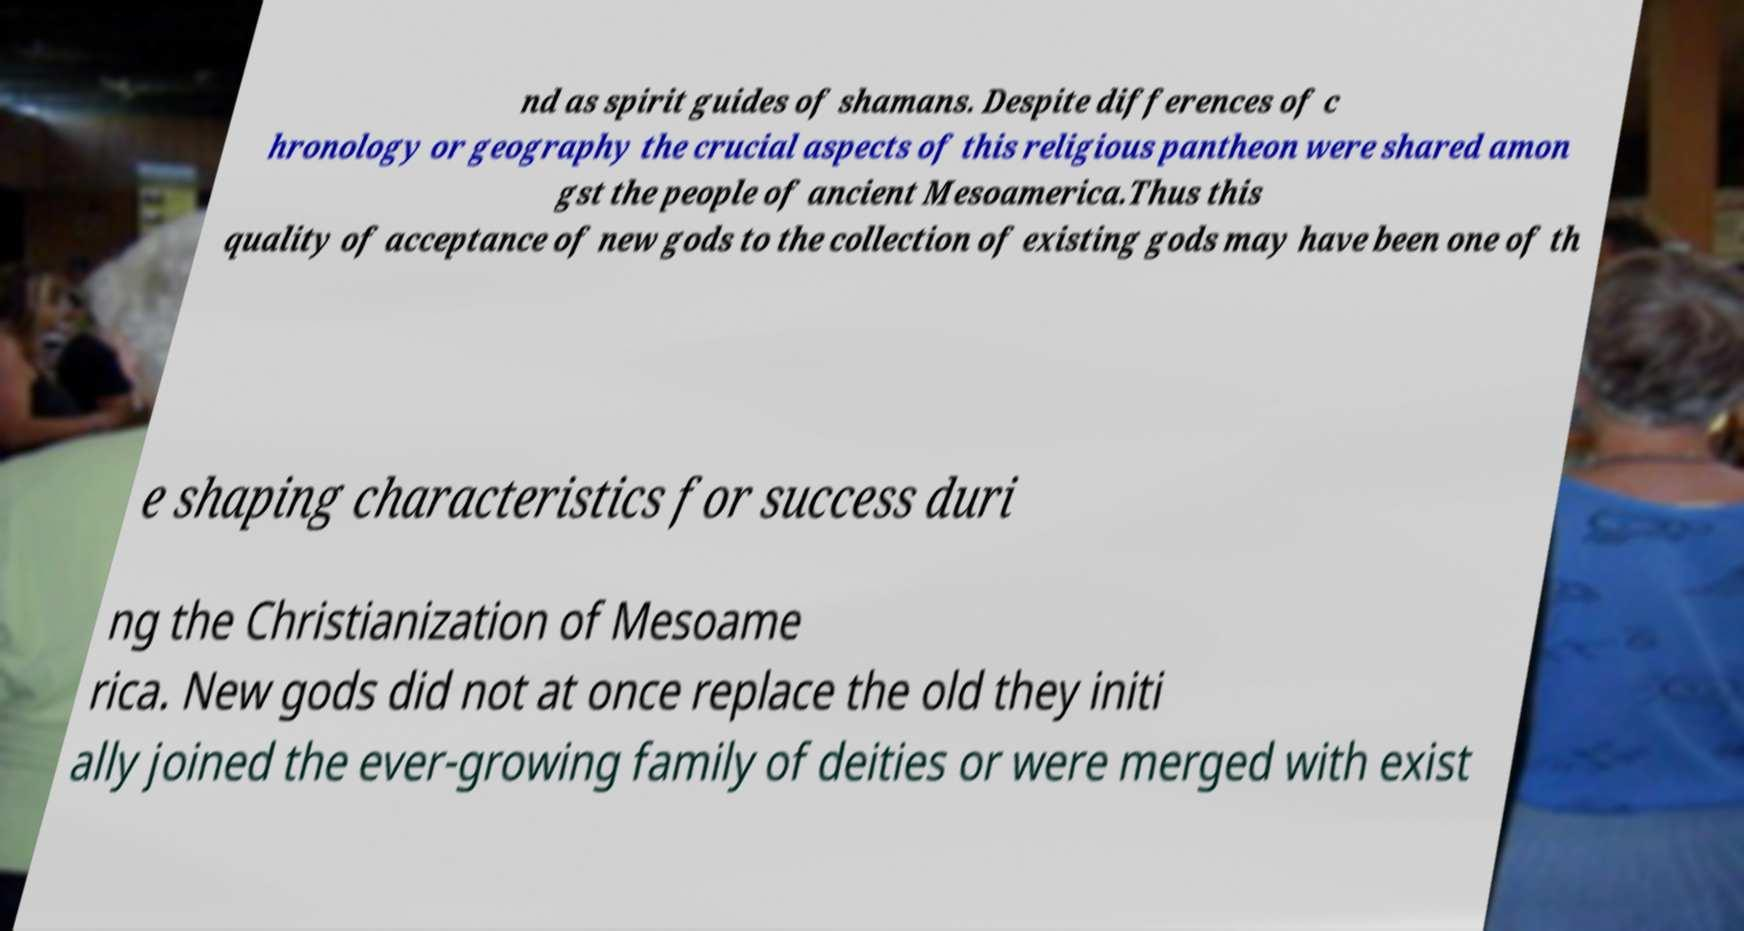Please read and relay the text visible in this image. What does it say? nd as spirit guides of shamans. Despite differences of c hronology or geography the crucial aspects of this religious pantheon were shared amon gst the people of ancient Mesoamerica.Thus this quality of acceptance of new gods to the collection of existing gods may have been one of th e shaping characteristics for success duri ng the Christianization of Mesoame rica. New gods did not at once replace the old they initi ally joined the ever-growing family of deities or were merged with exist 